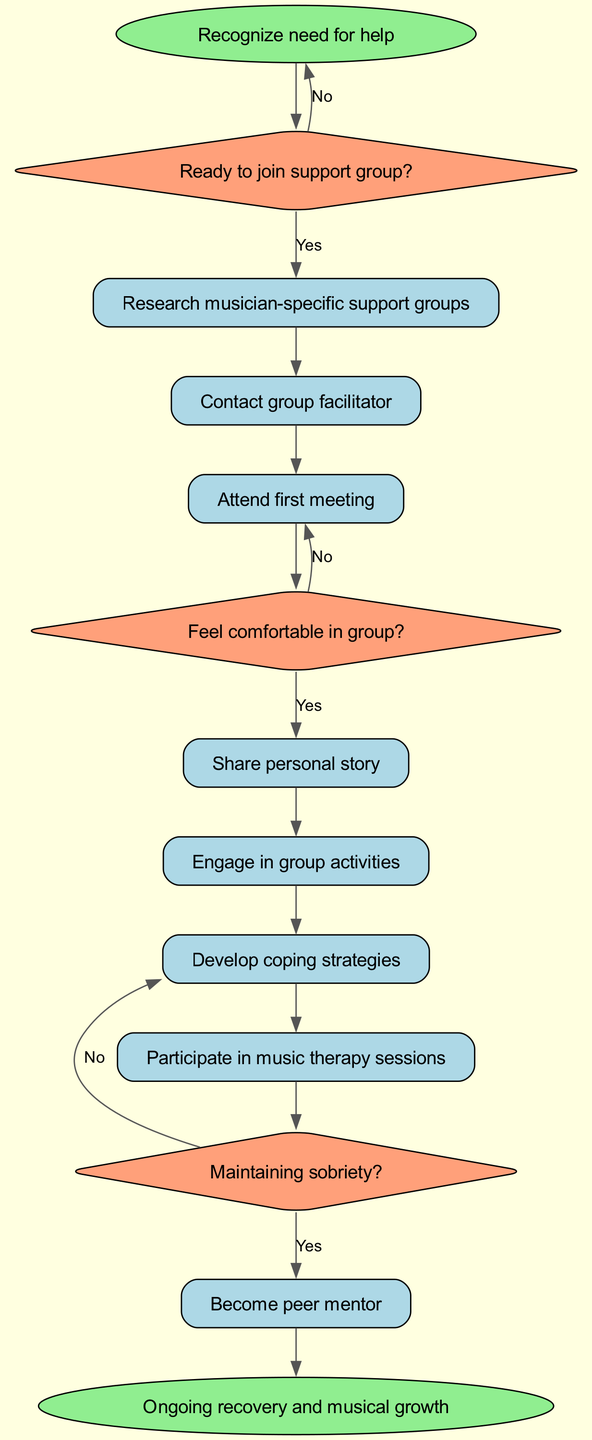What is the starting point of the flowchart? The starting point (or the first node) in the flowchart is "Recognize need for help." This is indicated as the initial action before any decisions are made.
Answer: Recognize need for help What shape represents decision nodes in the diagram? The decision nodes in the diagram are represented by diamonds. These shapes indicate points where a choice must be made, leading to different actions based on the outcome.
Answer: Diamond How many action nodes are there in total? The diagram contains a total of six action nodes, which represent specific steps or activities that can be taken after decisions are made.
Answer: Six What happens if someone is not ready to join a support group? If someone is not ready to join, they loop back to the starting point, "Recognize need for help." This means they have to reconsider their situation before proceeding further.
Answer: Go back to start What action follows after attending the first meeting? After attending the first meeting, the next decision to consider is whether the participant feels comfortable in the group. This initiates the reasoning process for further engagement.
Answer: Feel comfortable in group? If someone does not maintain sobriety, what is the subsequent action? If a participant does not maintain sobriety, they proceed to develop coping strategies instead of becoming a peer mentor. This shows the option to improve personal well-being rather than take on a mentoring role.
Answer: Develop coping strategies Which action occurs just before becoming a peer mentor? The action that occurs just before becoming a peer mentor is to participate in music therapy sessions. This indicates a preparatory step for those wishing to support others while also focusing on their recovery.
Answer: Participate in music therapy sessions What is the final endpoint of the flowchart? The final endpoint of the flowchart is "Ongoing recovery and musical growth." This reflects the ultimate goal of participating in the support group process for musicians overcoming addiction.
Answer: Ongoing recovery and musical growth 